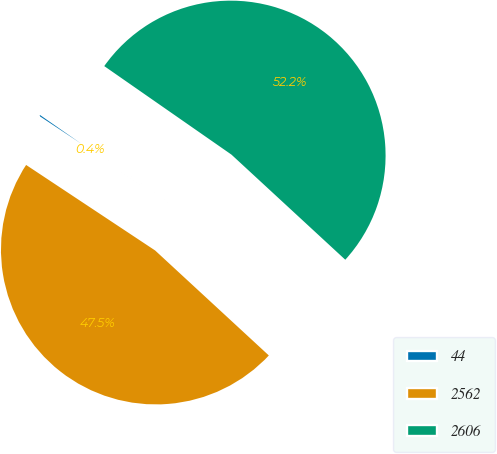Convert chart. <chart><loc_0><loc_0><loc_500><loc_500><pie_chart><fcel>44<fcel>2562<fcel>2606<nl><fcel>0.36%<fcel>47.45%<fcel>52.19%<nl></chart> 